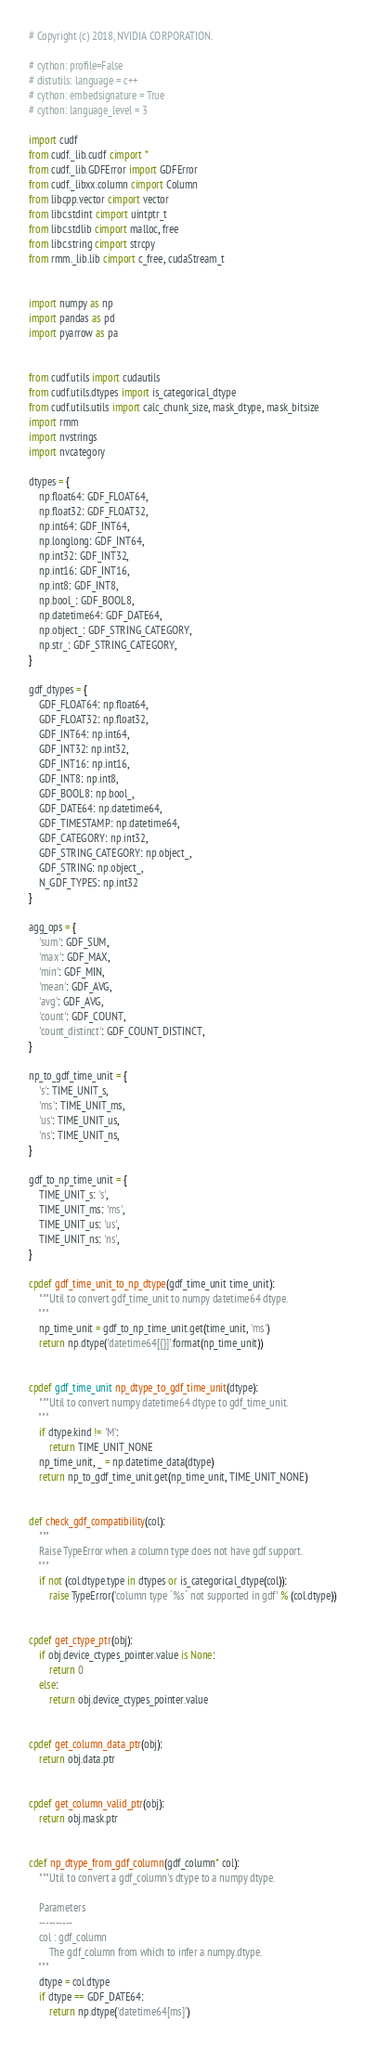Convert code to text. <code><loc_0><loc_0><loc_500><loc_500><_Cython_># Copyright (c) 2018, NVIDIA CORPORATION.

# cython: profile=False
# distutils: language = c++
# cython: embedsignature = True
# cython: language_level = 3

import cudf
from cudf._lib.cudf cimport *
from cudf._lib.GDFError import GDFError
from cudf._libxx.column cimport Column
from libcpp.vector cimport vector
from libc.stdint cimport uintptr_t
from libc.stdlib cimport malloc, free
from libc.string cimport strcpy
from rmm._lib.lib cimport c_free, cudaStream_t


import numpy as np
import pandas as pd
import pyarrow as pa


from cudf.utils import cudautils
from cudf.utils.dtypes import is_categorical_dtype
from cudf.utils.utils import calc_chunk_size, mask_dtype, mask_bitsize
import rmm
import nvstrings
import nvcategory

dtypes = {
    np.float64: GDF_FLOAT64,
    np.float32: GDF_FLOAT32,
    np.int64: GDF_INT64,
    np.longlong: GDF_INT64,
    np.int32: GDF_INT32,
    np.int16: GDF_INT16,
    np.int8: GDF_INT8,
    np.bool_: GDF_BOOL8,
    np.datetime64: GDF_DATE64,
    np.object_: GDF_STRING_CATEGORY,
    np.str_: GDF_STRING_CATEGORY,
}

gdf_dtypes = {
    GDF_FLOAT64: np.float64,
    GDF_FLOAT32: np.float32,
    GDF_INT64: np.int64,
    GDF_INT32: np.int32,
    GDF_INT16: np.int16,
    GDF_INT8: np.int8,
    GDF_BOOL8: np.bool_,
    GDF_DATE64: np.datetime64,
    GDF_TIMESTAMP: np.datetime64,
    GDF_CATEGORY: np.int32,
    GDF_STRING_CATEGORY: np.object_,
    GDF_STRING: np.object_,
    N_GDF_TYPES: np.int32
}

agg_ops = {
    'sum': GDF_SUM,
    'max': GDF_MAX,
    'min': GDF_MIN,
    'mean': GDF_AVG,
    'avg': GDF_AVG,
    'count': GDF_COUNT,
    'count_distinct': GDF_COUNT_DISTINCT,
}

np_to_gdf_time_unit = {
    's': TIME_UNIT_s,
    'ms': TIME_UNIT_ms,
    'us': TIME_UNIT_us,
    'ns': TIME_UNIT_ns,
}

gdf_to_np_time_unit = {
    TIME_UNIT_s: 's',
    TIME_UNIT_ms: 'ms',
    TIME_UNIT_us: 'us',
    TIME_UNIT_ns: 'ns',
}

cpdef gdf_time_unit_to_np_dtype(gdf_time_unit time_unit):
    """Util to convert gdf_time_unit to numpy datetime64 dtype.
    """
    np_time_unit = gdf_to_np_time_unit.get(time_unit, 'ms')
    return np.dtype('datetime64[{}]'.format(np_time_unit))


cpdef gdf_time_unit np_dtype_to_gdf_time_unit(dtype):
    """Util to convert numpy datetime64 dtype to gdf_time_unit.
    """
    if dtype.kind != 'M':
        return TIME_UNIT_NONE
    np_time_unit, _ = np.datetime_data(dtype)
    return np_to_gdf_time_unit.get(np_time_unit, TIME_UNIT_NONE)


def check_gdf_compatibility(col):
    """
    Raise TypeError when a column type does not have gdf support.
    """
    if not (col.dtype.type in dtypes or is_categorical_dtype(col)):
        raise TypeError('column type `%s` not supported in gdf' % (col.dtype))


cpdef get_ctype_ptr(obj):
    if obj.device_ctypes_pointer.value is None:
        return 0
    else:
        return obj.device_ctypes_pointer.value


cpdef get_column_data_ptr(obj):
    return obj.data.ptr


cpdef get_column_valid_ptr(obj):
    return obj.mask.ptr


cdef np_dtype_from_gdf_column(gdf_column* col):
    """Util to convert a gdf_column's dtype to a numpy dtype.

    Parameters
    ----------
    col : gdf_column
        The gdf_column from which to infer a numpy.dtype.
    """
    dtype = col.dtype
    if dtype == GDF_DATE64:
        return np.dtype('datetime64[ms]')</code> 